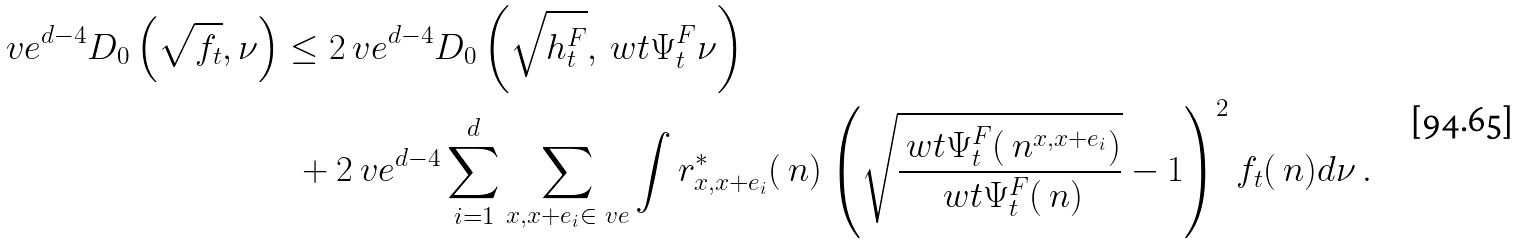<formula> <loc_0><loc_0><loc_500><loc_500>\ v e ^ { d - 4 } D _ { 0 } \left ( \sqrt { f _ { t } } , \nu \right ) & \leq 2 \ v e ^ { d - 4 } D _ { 0 } \left ( \sqrt { h _ { t } ^ { F } } , \ w t { \Psi } _ { t } ^ { F } \nu \right ) \\ \ & \ \ + 2 \ v e ^ { d - 4 } \sum _ { i = 1 } ^ { d } \sum _ { x , x + e _ { i } \in \L _ { \ } v e } \int r _ { x , x + e _ { i } } ^ { * } ( \ n ) \left ( \sqrt { \frac { \ w t { \Psi } _ { t } ^ { F } ( \ n ^ { x , x + e _ { i } } ) } { \ w t { \Psi } _ { t } ^ { F } ( \ n ) } } - 1 \right ) ^ { 2 } f _ { t } ( \ n ) d \nu \, . \\</formula> 